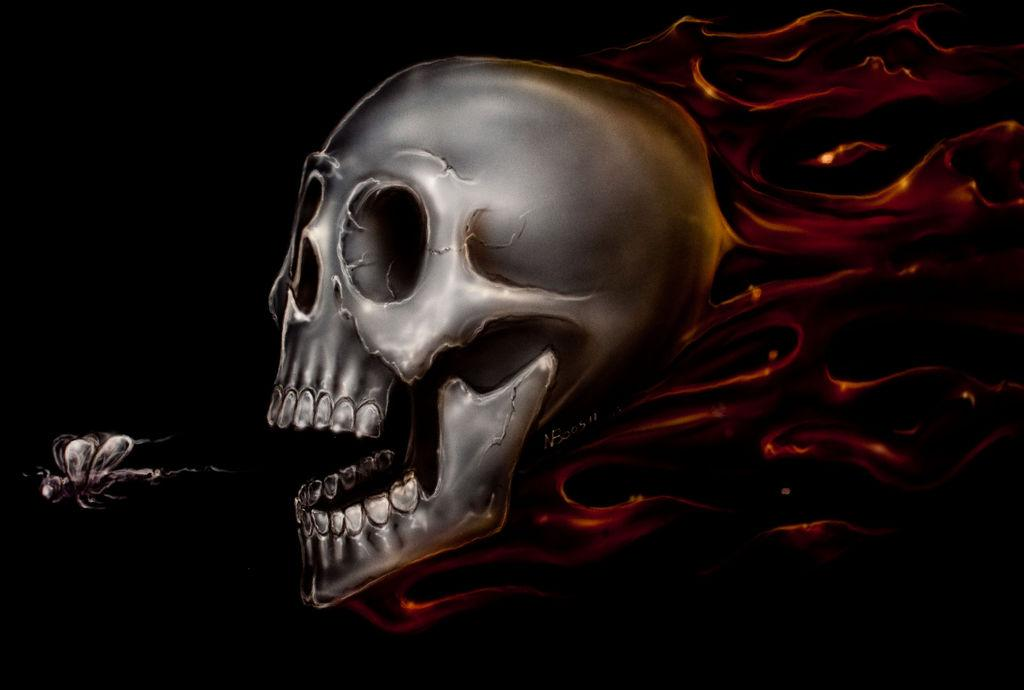What type of image is being described? The image is animated. What is the main subject of the image? There is a skull in the image. What is visible behind the skull? There is a design behind the skull. Can you describe any other elements in the image? There is an insect on the left side of the image. What type of monkey can be seen interacting with the father and friends in the image? There is no monkey, father, or friends present in the image; it features an animated skull with a design behind it and an insect on the left side. 